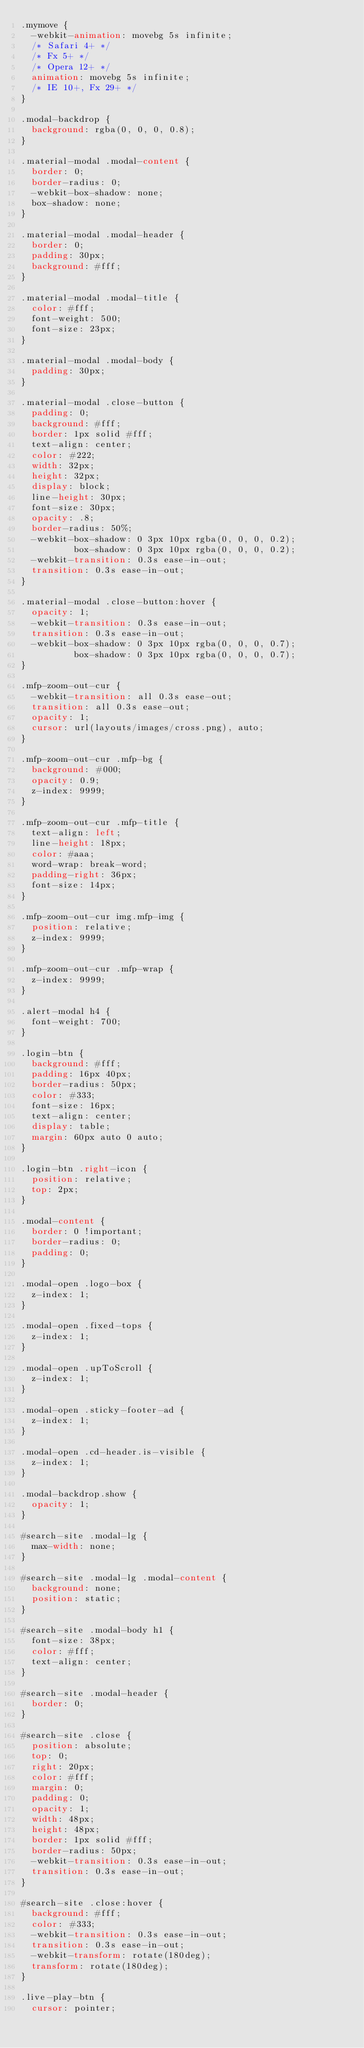<code> <loc_0><loc_0><loc_500><loc_500><_CSS_>.mymove {
  -webkit-animation: movebg 5s infinite;
  /* Safari 4+ */
  /* Fx 5+ */
  /* Opera 12+ */
  animation: movebg 5s infinite;
  /* IE 10+, Fx 29+ */
}

.modal-backdrop {
  background: rgba(0, 0, 0, 0.8);
}

.material-modal .modal-content {
  border: 0;
  border-radius: 0;
  -webkit-box-shadow: none;
  box-shadow: none;
}

.material-modal .modal-header {
  border: 0;
  padding: 30px;
  background: #fff;
}

.material-modal .modal-title {
  color: #fff;
  font-weight: 500;
  font-size: 23px;
}

.material-modal .modal-body {
  padding: 30px;
}

.material-modal .close-button {
  padding: 0;
  background: #fff;
  border: 1px solid #fff;
  text-align: center;
  color: #222;
  width: 32px;
  height: 32px;
  display: block;
  line-height: 30px;
  font-size: 30px;
  opacity: .8;
  border-radius: 50%;
  -webkit-box-shadow: 0 3px 10px rgba(0, 0, 0, 0.2);
          box-shadow: 0 3px 10px rgba(0, 0, 0, 0.2);
  -webkit-transition: 0.3s ease-in-out;
  transition: 0.3s ease-in-out;
}

.material-modal .close-button:hover {
  opacity: 1;
  -webkit-transition: 0.3s ease-in-out;
  transition: 0.3s ease-in-out;
  -webkit-box-shadow: 0 3px 10px rgba(0, 0, 0, 0.7);
          box-shadow: 0 3px 10px rgba(0, 0, 0, 0.7);
}

.mfp-zoom-out-cur {
  -webkit-transition: all 0.3s ease-out;
  transition: all 0.3s ease-out;
  opacity: 1;
  cursor: url(layouts/images/cross.png), auto;
}

.mfp-zoom-out-cur .mfp-bg {
  background: #000;
  opacity: 0.9;
  z-index: 9999;
}

.mfp-zoom-out-cur .mfp-title {
  text-align: left;
  line-height: 18px;
  color: #aaa;
  word-wrap: break-word;
  padding-right: 36px;
  font-size: 14px;
}

.mfp-zoom-out-cur img.mfp-img {
  position: relative;
  z-index: 9999;
}

.mfp-zoom-out-cur .mfp-wrap {
  z-index: 9999;
}

.alert-modal h4 {
  font-weight: 700;
}

.login-btn {
  background: #fff;
  padding: 16px 40px;
  border-radius: 50px;
  color: #333;
  font-size: 16px;
  text-align: center;
  display: table;
  margin: 60px auto 0 auto;
}

.login-btn .right-icon {
  position: relative;
  top: 2px;
}

.modal-content {
  border: 0 !important;
  border-radius: 0;
  padding: 0;
}

.modal-open .logo-box {
  z-index: 1;
}

.modal-open .fixed-tops {
  z-index: 1;
}

.modal-open .upToScroll {
  z-index: 1;
}

.modal-open .sticky-footer-ad {
  z-index: 1;
}

.modal-open .cd-header.is-visible {
  z-index: 1;
}

.modal-backdrop.show {
  opacity: 1;
}

#search-site .modal-lg {
  max-width: none;
}

#search-site .modal-lg .modal-content {
  background: none;
  position: static;
}

#search-site .modal-body h1 {
  font-size: 38px;
  color: #fff;
  text-align: center;
}

#search-site .modal-header {
  border: 0;
}

#search-site .close {
  position: absolute;
  top: 0;
  right: 20px;
  color: #fff;
  margin: 0;
  padding: 0;
  opacity: 1;
  width: 48px;
  height: 48px;
  border: 1px solid #fff;
  border-radius: 50px;
  -webkit-transition: 0.3s ease-in-out;
  transition: 0.3s ease-in-out;
}

#search-site .close:hover {
  background: #fff;
  color: #333;
  -webkit-transition: 0.3s ease-in-out;
  transition: 0.3s ease-in-out;
  -webkit-transform: rotate(180deg);
  transform: rotate(180deg);
}

.live-play-btn {
  cursor: pointer;</code> 